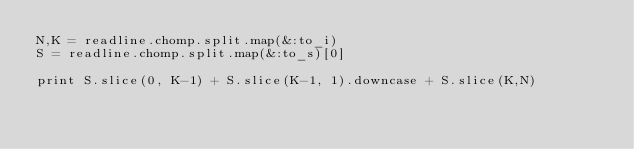<code> <loc_0><loc_0><loc_500><loc_500><_Ruby_>N,K = readline.chomp.split.map(&:to_i)
S = readline.chomp.split.map(&:to_s)[0]

print S.slice(0, K-1) + S.slice(K-1, 1).downcase + S.slice(K,N)</code> 